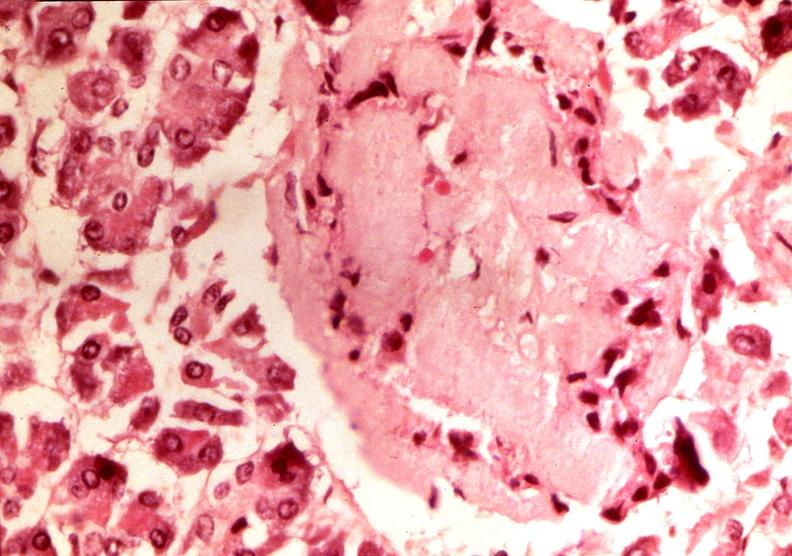s lower chest and abdomen anterior present?
Answer the question using a single word or phrase. No 